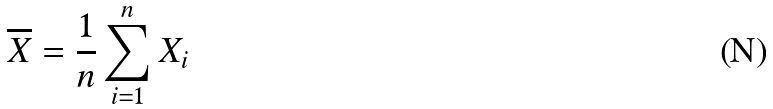Convert formula to latex. <formula><loc_0><loc_0><loc_500><loc_500>\overline { X } = \frac { 1 } { n } \sum _ { i = 1 } ^ { n } X _ { i }</formula> 